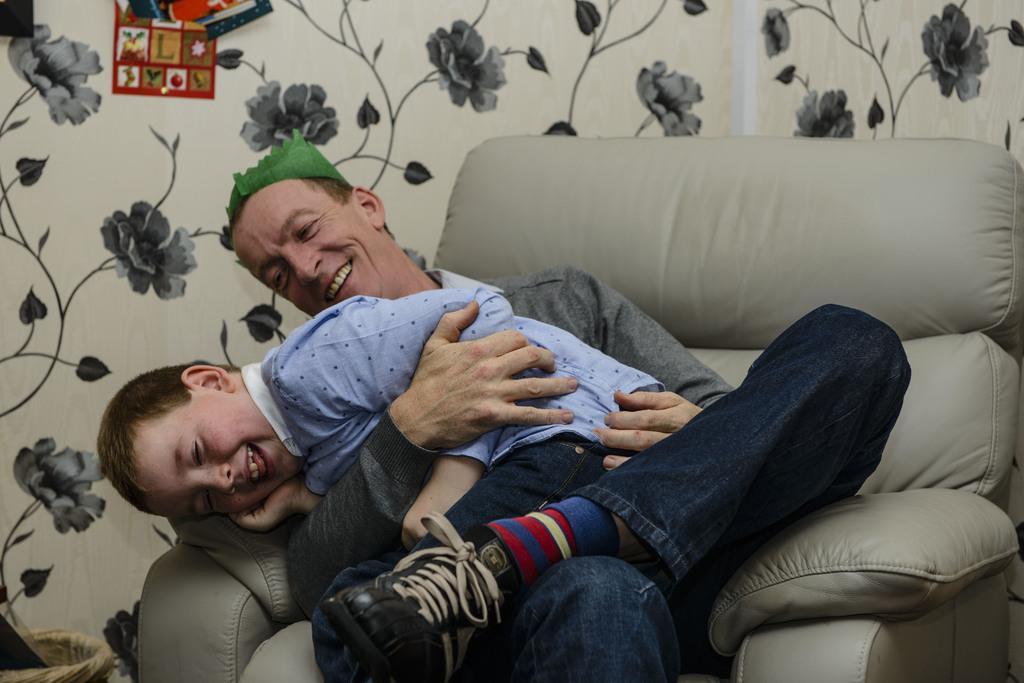In one or two sentences, can you explain what this image depicts? The image is inside the room. In the image there are two people man and a boy are sitting on couch, in background we can also see some flowers. 